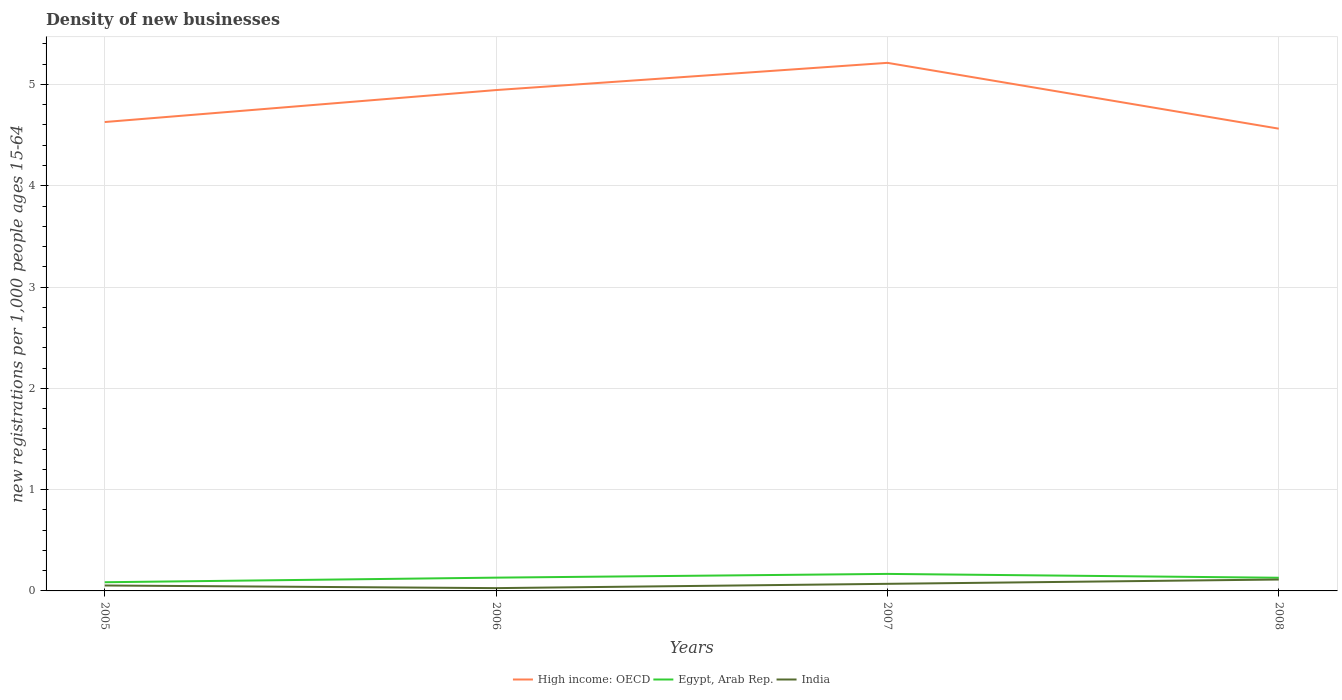Does the line corresponding to India intersect with the line corresponding to High income: OECD?
Keep it short and to the point. No. Is the number of lines equal to the number of legend labels?
Your answer should be very brief. Yes. Across all years, what is the maximum number of new registrations in High income: OECD?
Your answer should be very brief. 4.56. In which year was the number of new registrations in High income: OECD maximum?
Provide a short and direct response. 2008. What is the total number of new registrations in India in the graph?
Ensure brevity in your answer.  -0.09. What is the difference between the highest and the second highest number of new registrations in Egypt, Arab Rep.?
Provide a succinct answer. 0.08. What is the difference between the highest and the lowest number of new registrations in Egypt, Arab Rep.?
Make the answer very short. 3. How many legend labels are there?
Provide a succinct answer. 3. What is the title of the graph?
Your response must be concise. Density of new businesses. What is the label or title of the Y-axis?
Offer a terse response. New registrations per 1,0 people ages 15-64. What is the new registrations per 1,000 people ages 15-64 of High income: OECD in 2005?
Your answer should be compact. 4.63. What is the new registrations per 1,000 people ages 15-64 of Egypt, Arab Rep. in 2005?
Provide a succinct answer. 0.09. What is the new registrations per 1,000 people ages 15-64 of India in 2005?
Your response must be concise. 0.05. What is the new registrations per 1,000 people ages 15-64 of High income: OECD in 2006?
Provide a succinct answer. 4.94. What is the new registrations per 1,000 people ages 15-64 of Egypt, Arab Rep. in 2006?
Ensure brevity in your answer.  0.13. What is the new registrations per 1,000 people ages 15-64 in India in 2006?
Your answer should be very brief. 0.03. What is the new registrations per 1,000 people ages 15-64 of High income: OECD in 2007?
Keep it short and to the point. 5.21. What is the new registrations per 1,000 people ages 15-64 in Egypt, Arab Rep. in 2007?
Keep it short and to the point. 0.17. What is the new registrations per 1,000 people ages 15-64 of India in 2007?
Make the answer very short. 0.07. What is the new registrations per 1,000 people ages 15-64 in High income: OECD in 2008?
Ensure brevity in your answer.  4.56. What is the new registrations per 1,000 people ages 15-64 of Egypt, Arab Rep. in 2008?
Keep it short and to the point. 0.13. What is the new registrations per 1,000 people ages 15-64 in India in 2008?
Provide a succinct answer. 0.11. Across all years, what is the maximum new registrations per 1,000 people ages 15-64 of High income: OECD?
Make the answer very short. 5.21. Across all years, what is the maximum new registrations per 1,000 people ages 15-64 in Egypt, Arab Rep.?
Ensure brevity in your answer.  0.17. Across all years, what is the maximum new registrations per 1,000 people ages 15-64 of India?
Your response must be concise. 0.11. Across all years, what is the minimum new registrations per 1,000 people ages 15-64 of High income: OECD?
Offer a terse response. 4.56. Across all years, what is the minimum new registrations per 1,000 people ages 15-64 in Egypt, Arab Rep.?
Offer a terse response. 0.09. Across all years, what is the minimum new registrations per 1,000 people ages 15-64 of India?
Your response must be concise. 0.03. What is the total new registrations per 1,000 people ages 15-64 in High income: OECD in the graph?
Provide a succinct answer. 19.35. What is the total new registrations per 1,000 people ages 15-64 of Egypt, Arab Rep. in the graph?
Your answer should be compact. 0.51. What is the total new registrations per 1,000 people ages 15-64 in India in the graph?
Make the answer very short. 0.26. What is the difference between the new registrations per 1,000 people ages 15-64 of High income: OECD in 2005 and that in 2006?
Your response must be concise. -0.32. What is the difference between the new registrations per 1,000 people ages 15-64 of Egypt, Arab Rep. in 2005 and that in 2006?
Provide a short and direct response. -0.05. What is the difference between the new registrations per 1,000 people ages 15-64 of India in 2005 and that in 2006?
Provide a short and direct response. 0.03. What is the difference between the new registrations per 1,000 people ages 15-64 of High income: OECD in 2005 and that in 2007?
Provide a short and direct response. -0.58. What is the difference between the new registrations per 1,000 people ages 15-64 in Egypt, Arab Rep. in 2005 and that in 2007?
Your response must be concise. -0.08. What is the difference between the new registrations per 1,000 people ages 15-64 of India in 2005 and that in 2007?
Keep it short and to the point. -0.02. What is the difference between the new registrations per 1,000 people ages 15-64 in High income: OECD in 2005 and that in 2008?
Keep it short and to the point. 0.07. What is the difference between the new registrations per 1,000 people ages 15-64 in Egypt, Arab Rep. in 2005 and that in 2008?
Give a very brief answer. -0.04. What is the difference between the new registrations per 1,000 people ages 15-64 in India in 2005 and that in 2008?
Provide a succinct answer. -0.06. What is the difference between the new registrations per 1,000 people ages 15-64 of High income: OECD in 2006 and that in 2007?
Your answer should be very brief. -0.27. What is the difference between the new registrations per 1,000 people ages 15-64 in Egypt, Arab Rep. in 2006 and that in 2007?
Offer a very short reply. -0.04. What is the difference between the new registrations per 1,000 people ages 15-64 of India in 2006 and that in 2007?
Make the answer very short. -0.04. What is the difference between the new registrations per 1,000 people ages 15-64 in High income: OECD in 2006 and that in 2008?
Offer a very short reply. 0.38. What is the difference between the new registrations per 1,000 people ages 15-64 in Egypt, Arab Rep. in 2006 and that in 2008?
Give a very brief answer. 0. What is the difference between the new registrations per 1,000 people ages 15-64 in India in 2006 and that in 2008?
Keep it short and to the point. -0.09. What is the difference between the new registrations per 1,000 people ages 15-64 in High income: OECD in 2007 and that in 2008?
Offer a very short reply. 0.65. What is the difference between the new registrations per 1,000 people ages 15-64 of Egypt, Arab Rep. in 2007 and that in 2008?
Your answer should be compact. 0.04. What is the difference between the new registrations per 1,000 people ages 15-64 in India in 2007 and that in 2008?
Provide a succinct answer. -0.04. What is the difference between the new registrations per 1,000 people ages 15-64 in High income: OECD in 2005 and the new registrations per 1,000 people ages 15-64 in Egypt, Arab Rep. in 2006?
Your answer should be very brief. 4.5. What is the difference between the new registrations per 1,000 people ages 15-64 of High income: OECD in 2005 and the new registrations per 1,000 people ages 15-64 of India in 2006?
Provide a short and direct response. 4.6. What is the difference between the new registrations per 1,000 people ages 15-64 of Egypt, Arab Rep. in 2005 and the new registrations per 1,000 people ages 15-64 of India in 2006?
Provide a short and direct response. 0.06. What is the difference between the new registrations per 1,000 people ages 15-64 in High income: OECD in 2005 and the new registrations per 1,000 people ages 15-64 in Egypt, Arab Rep. in 2007?
Your response must be concise. 4.46. What is the difference between the new registrations per 1,000 people ages 15-64 in High income: OECD in 2005 and the new registrations per 1,000 people ages 15-64 in India in 2007?
Your answer should be compact. 4.56. What is the difference between the new registrations per 1,000 people ages 15-64 of Egypt, Arab Rep. in 2005 and the new registrations per 1,000 people ages 15-64 of India in 2007?
Give a very brief answer. 0.02. What is the difference between the new registrations per 1,000 people ages 15-64 in High income: OECD in 2005 and the new registrations per 1,000 people ages 15-64 in Egypt, Arab Rep. in 2008?
Offer a terse response. 4.5. What is the difference between the new registrations per 1,000 people ages 15-64 in High income: OECD in 2005 and the new registrations per 1,000 people ages 15-64 in India in 2008?
Make the answer very short. 4.52. What is the difference between the new registrations per 1,000 people ages 15-64 in Egypt, Arab Rep. in 2005 and the new registrations per 1,000 people ages 15-64 in India in 2008?
Provide a succinct answer. -0.03. What is the difference between the new registrations per 1,000 people ages 15-64 in High income: OECD in 2006 and the new registrations per 1,000 people ages 15-64 in Egypt, Arab Rep. in 2007?
Make the answer very short. 4.78. What is the difference between the new registrations per 1,000 people ages 15-64 in High income: OECD in 2006 and the new registrations per 1,000 people ages 15-64 in India in 2007?
Offer a terse response. 4.87. What is the difference between the new registrations per 1,000 people ages 15-64 of Egypt, Arab Rep. in 2006 and the new registrations per 1,000 people ages 15-64 of India in 2007?
Make the answer very short. 0.06. What is the difference between the new registrations per 1,000 people ages 15-64 of High income: OECD in 2006 and the new registrations per 1,000 people ages 15-64 of Egypt, Arab Rep. in 2008?
Your response must be concise. 4.81. What is the difference between the new registrations per 1,000 people ages 15-64 of High income: OECD in 2006 and the new registrations per 1,000 people ages 15-64 of India in 2008?
Provide a succinct answer. 4.83. What is the difference between the new registrations per 1,000 people ages 15-64 of Egypt, Arab Rep. in 2006 and the new registrations per 1,000 people ages 15-64 of India in 2008?
Ensure brevity in your answer.  0.02. What is the difference between the new registrations per 1,000 people ages 15-64 in High income: OECD in 2007 and the new registrations per 1,000 people ages 15-64 in Egypt, Arab Rep. in 2008?
Give a very brief answer. 5.08. What is the difference between the new registrations per 1,000 people ages 15-64 in High income: OECD in 2007 and the new registrations per 1,000 people ages 15-64 in India in 2008?
Your response must be concise. 5.1. What is the difference between the new registrations per 1,000 people ages 15-64 in Egypt, Arab Rep. in 2007 and the new registrations per 1,000 people ages 15-64 in India in 2008?
Your answer should be very brief. 0.06. What is the average new registrations per 1,000 people ages 15-64 in High income: OECD per year?
Provide a succinct answer. 4.84. What is the average new registrations per 1,000 people ages 15-64 of Egypt, Arab Rep. per year?
Keep it short and to the point. 0.13. What is the average new registrations per 1,000 people ages 15-64 of India per year?
Offer a terse response. 0.07. In the year 2005, what is the difference between the new registrations per 1,000 people ages 15-64 in High income: OECD and new registrations per 1,000 people ages 15-64 in Egypt, Arab Rep.?
Make the answer very short. 4.54. In the year 2005, what is the difference between the new registrations per 1,000 people ages 15-64 of High income: OECD and new registrations per 1,000 people ages 15-64 of India?
Ensure brevity in your answer.  4.58. In the year 2005, what is the difference between the new registrations per 1,000 people ages 15-64 of Egypt, Arab Rep. and new registrations per 1,000 people ages 15-64 of India?
Keep it short and to the point. 0.03. In the year 2006, what is the difference between the new registrations per 1,000 people ages 15-64 of High income: OECD and new registrations per 1,000 people ages 15-64 of Egypt, Arab Rep.?
Provide a short and direct response. 4.81. In the year 2006, what is the difference between the new registrations per 1,000 people ages 15-64 of High income: OECD and new registrations per 1,000 people ages 15-64 of India?
Provide a succinct answer. 4.92. In the year 2006, what is the difference between the new registrations per 1,000 people ages 15-64 of Egypt, Arab Rep. and new registrations per 1,000 people ages 15-64 of India?
Your answer should be very brief. 0.1. In the year 2007, what is the difference between the new registrations per 1,000 people ages 15-64 of High income: OECD and new registrations per 1,000 people ages 15-64 of Egypt, Arab Rep.?
Provide a succinct answer. 5.05. In the year 2007, what is the difference between the new registrations per 1,000 people ages 15-64 in High income: OECD and new registrations per 1,000 people ages 15-64 in India?
Your answer should be compact. 5.14. In the year 2007, what is the difference between the new registrations per 1,000 people ages 15-64 of Egypt, Arab Rep. and new registrations per 1,000 people ages 15-64 of India?
Your answer should be very brief. 0.1. In the year 2008, what is the difference between the new registrations per 1,000 people ages 15-64 of High income: OECD and new registrations per 1,000 people ages 15-64 of Egypt, Arab Rep.?
Your answer should be very brief. 4.43. In the year 2008, what is the difference between the new registrations per 1,000 people ages 15-64 in High income: OECD and new registrations per 1,000 people ages 15-64 in India?
Keep it short and to the point. 4.45. In the year 2008, what is the difference between the new registrations per 1,000 people ages 15-64 of Egypt, Arab Rep. and new registrations per 1,000 people ages 15-64 of India?
Offer a terse response. 0.02. What is the ratio of the new registrations per 1,000 people ages 15-64 of High income: OECD in 2005 to that in 2006?
Your answer should be compact. 0.94. What is the ratio of the new registrations per 1,000 people ages 15-64 of Egypt, Arab Rep. in 2005 to that in 2006?
Your answer should be compact. 0.65. What is the ratio of the new registrations per 1,000 people ages 15-64 of India in 2005 to that in 2006?
Provide a succinct answer. 1.94. What is the ratio of the new registrations per 1,000 people ages 15-64 of High income: OECD in 2005 to that in 2007?
Your answer should be very brief. 0.89. What is the ratio of the new registrations per 1,000 people ages 15-64 in Egypt, Arab Rep. in 2005 to that in 2007?
Your answer should be very brief. 0.51. What is the ratio of the new registrations per 1,000 people ages 15-64 in India in 2005 to that in 2007?
Offer a very short reply. 0.77. What is the ratio of the new registrations per 1,000 people ages 15-64 of High income: OECD in 2005 to that in 2008?
Your response must be concise. 1.01. What is the ratio of the new registrations per 1,000 people ages 15-64 of Egypt, Arab Rep. in 2005 to that in 2008?
Provide a short and direct response. 0.66. What is the ratio of the new registrations per 1,000 people ages 15-64 of India in 2005 to that in 2008?
Keep it short and to the point. 0.48. What is the ratio of the new registrations per 1,000 people ages 15-64 of High income: OECD in 2006 to that in 2007?
Your answer should be compact. 0.95. What is the ratio of the new registrations per 1,000 people ages 15-64 of Egypt, Arab Rep. in 2006 to that in 2007?
Your response must be concise. 0.78. What is the ratio of the new registrations per 1,000 people ages 15-64 of India in 2006 to that in 2007?
Keep it short and to the point. 0.39. What is the ratio of the new registrations per 1,000 people ages 15-64 of High income: OECD in 2006 to that in 2008?
Provide a short and direct response. 1.08. What is the ratio of the new registrations per 1,000 people ages 15-64 of Egypt, Arab Rep. in 2006 to that in 2008?
Offer a very short reply. 1.01. What is the ratio of the new registrations per 1,000 people ages 15-64 in India in 2006 to that in 2008?
Ensure brevity in your answer.  0.24. What is the ratio of the new registrations per 1,000 people ages 15-64 of High income: OECD in 2007 to that in 2008?
Ensure brevity in your answer.  1.14. What is the ratio of the new registrations per 1,000 people ages 15-64 of Egypt, Arab Rep. in 2007 to that in 2008?
Offer a terse response. 1.29. What is the ratio of the new registrations per 1,000 people ages 15-64 of India in 2007 to that in 2008?
Your answer should be very brief. 0.62. What is the difference between the highest and the second highest new registrations per 1,000 people ages 15-64 of High income: OECD?
Offer a terse response. 0.27. What is the difference between the highest and the second highest new registrations per 1,000 people ages 15-64 in Egypt, Arab Rep.?
Provide a short and direct response. 0.04. What is the difference between the highest and the second highest new registrations per 1,000 people ages 15-64 in India?
Give a very brief answer. 0.04. What is the difference between the highest and the lowest new registrations per 1,000 people ages 15-64 in High income: OECD?
Provide a short and direct response. 0.65. What is the difference between the highest and the lowest new registrations per 1,000 people ages 15-64 in Egypt, Arab Rep.?
Your answer should be compact. 0.08. What is the difference between the highest and the lowest new registrations per 1,000 people ages 15-64 of India?
Make the answer very short. 0.09. 